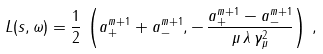Convert formula to latex. <formula><loc_0><loc_0><loc_500><loc_500>L ( s , \omega ) = \frac { 1 } { 2 } \, \left ( a _ { + } ^ { m + 1 } + a _ { - } ^ { m + 1 } , - \, \frac { a _ { + } ^ { m + 1 } - a _ { - } ^ { m + 1 } } { \mu \, \lambda \, \gamma _ { \mu } ^ { 2 } } \right ) \, ,</formula> 